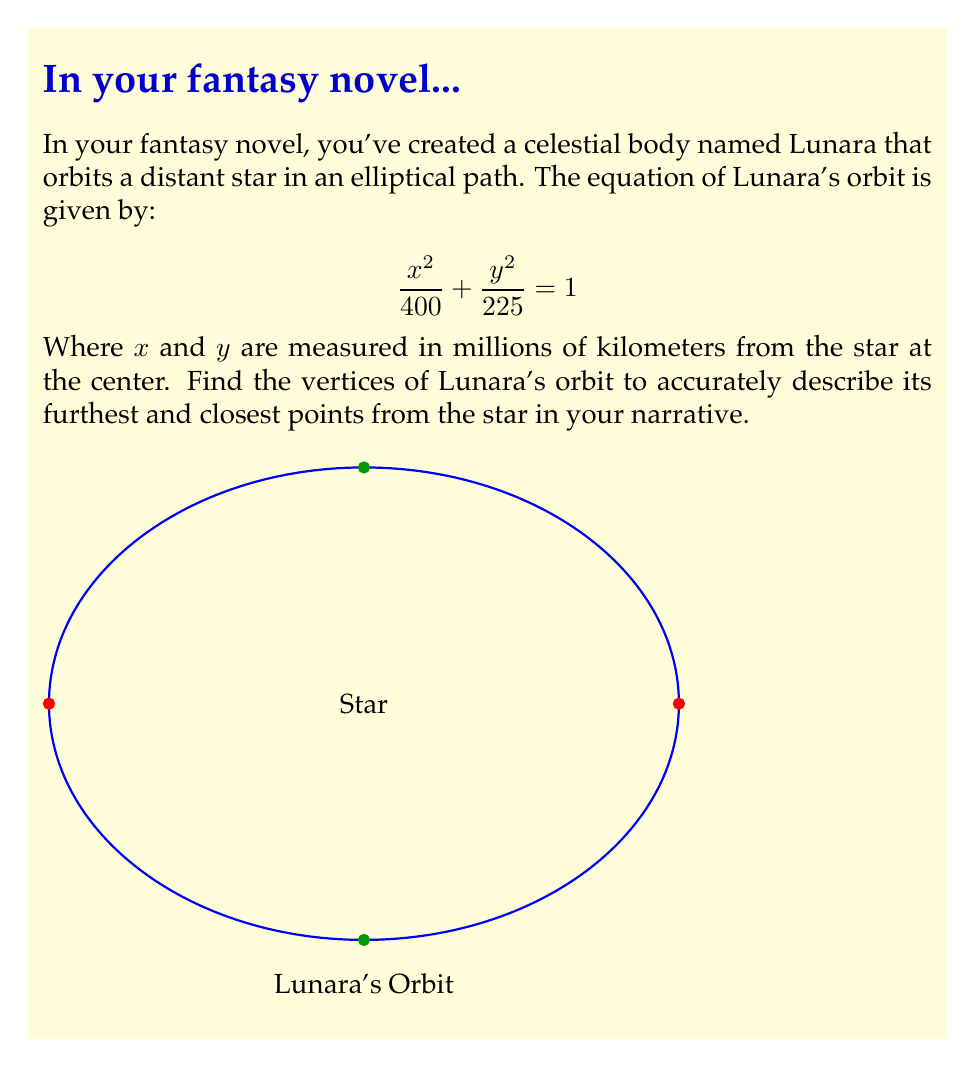Help me with this question. To find the vertices of Lunara's elliptical orbit, we need to follow these steps:

1) The general equation of an ellipse is:

   $$\frac{x^2}{a^2} + \frac{y^2}{b^2} = 1$$

   Where $a$ is the length of the semi-major axis and $b$ is the length of the semi-minor axis.

2) Comparing our given equation to the general form:

   $$\frac{x^2}{400} + \frac{y^2}{225} = 1$$

   We can see that $a^2 = 400$ and $b^2 = 225$

3) Taking the square root of both sides:

   $a = \sqrt{400} = 20$ million km
   $b = \sqrt{225} = 15$ million km

4) For an ellipse centered at the origin, the vertices are located at $(±a, 0)$ and $(0, ±b)$

5) Therefore, the vertices of Lunara's orbit are:
   - $(\pm20, 0)$ million km (on the x-axis)
   - $(0, \pm15)$ million km (on the y-axis)

These points represent the furthest (apoapsis) and closest (periapsis) points of Lunara's orbit from the star.
Answer: $(\pm20, 0)$ and $(0, \pm15)$ million km 